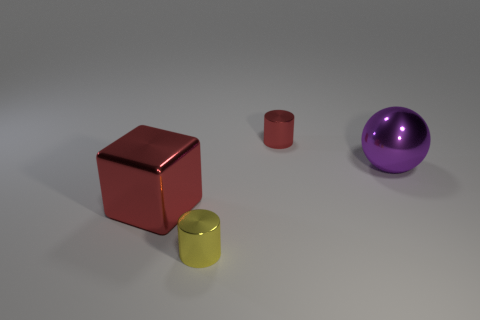Add 1 small red shiny objects. How many objects exist? 5 Subtract all spheres. How many objects are left? 3 Subtract all big green metal cylinders. Subtract all cylinders. How many objects are left? 2 Add 2 purple metallic objects. How many purple metallic objects are left? 3 Add 4 big purple things. How many big purple things exist? 5 Subtract 1 red blocks. How many objects are left? 3 